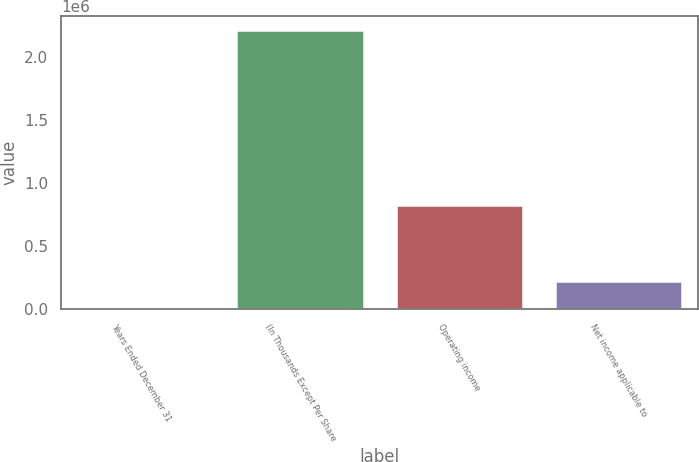Convert chart to OTSL. <chart><loc_0><loc_0><loc_500><loc_500><bar_chart><fcel>Years Ended December 31<fcel>(In Thousands Except Per Share<fcel>Operating income<fcel>Net income applicable to<nl><fcel>2003<fcel>2.21216e+06<fcel>823308<fcel>223019<nl></chart> 